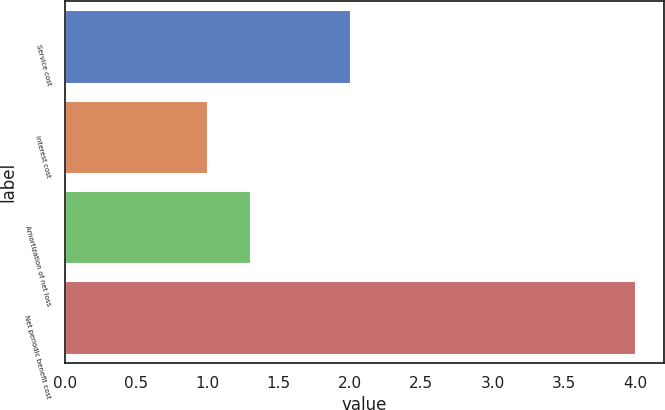Convert chart to OTSL. <chart><loc_0><loc_0><loc_500><loc_500><bar_chart><fcel>Service cost<fcel>Interest cost<fcel>Amortization of net loss<fcel>Net periodic benefit cost<nl><fcel>2<fcel>1<fcel>1.3<fcel>4<nl></chart> 